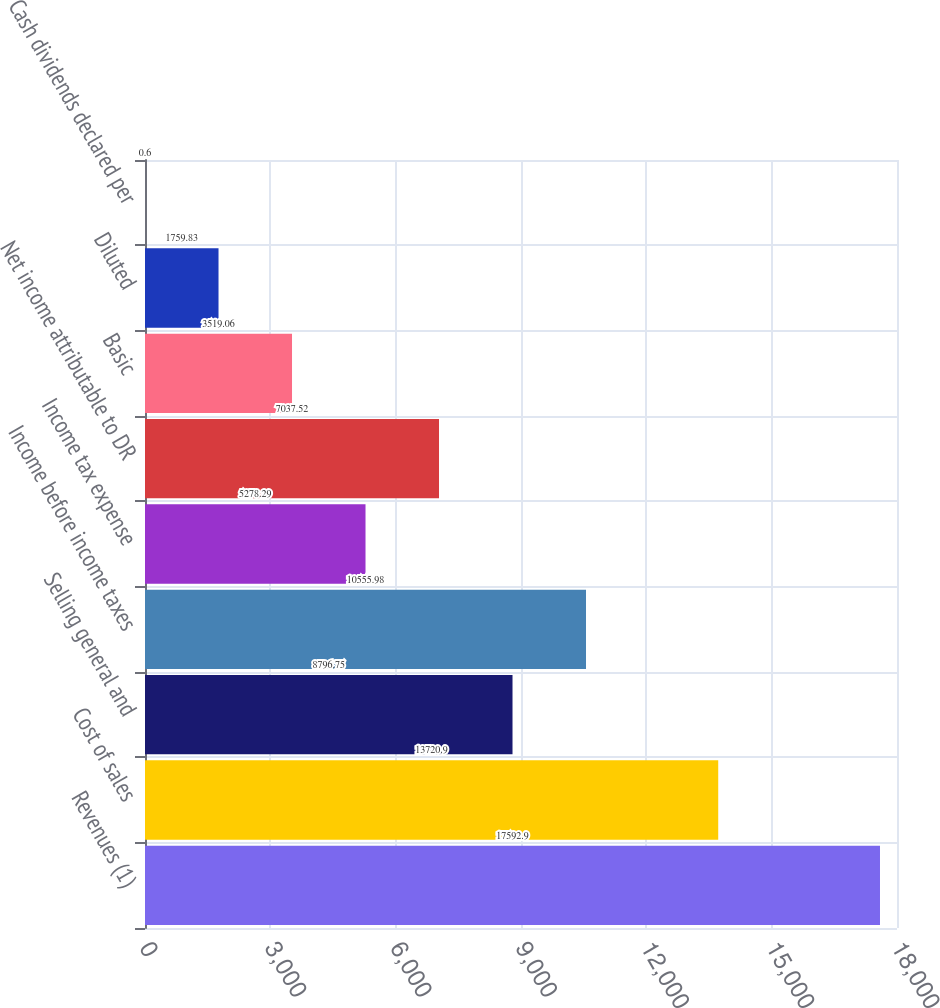Convert chart to OTSL. <chart><loc_0><loc_0><loc_500><loc_500><bar_chart><fcel>Revenues (1)<fcel>Cost of sales<fcel>Selling general and<fcel>Income before income taxes<fcel>Income tax expense<fcel>Net income attributable to DR<fcel>Basic<fcel>Diluted<fcel>Cash dividends declared per<nl><fcel>17592.9<fcel>13720.9<fcel>8796.75<fcel>10556<fcel>5278.29<fcel>7037.52<fcel>3519.06<fcel>1759.83<fcel>0.6<nl></chart> 